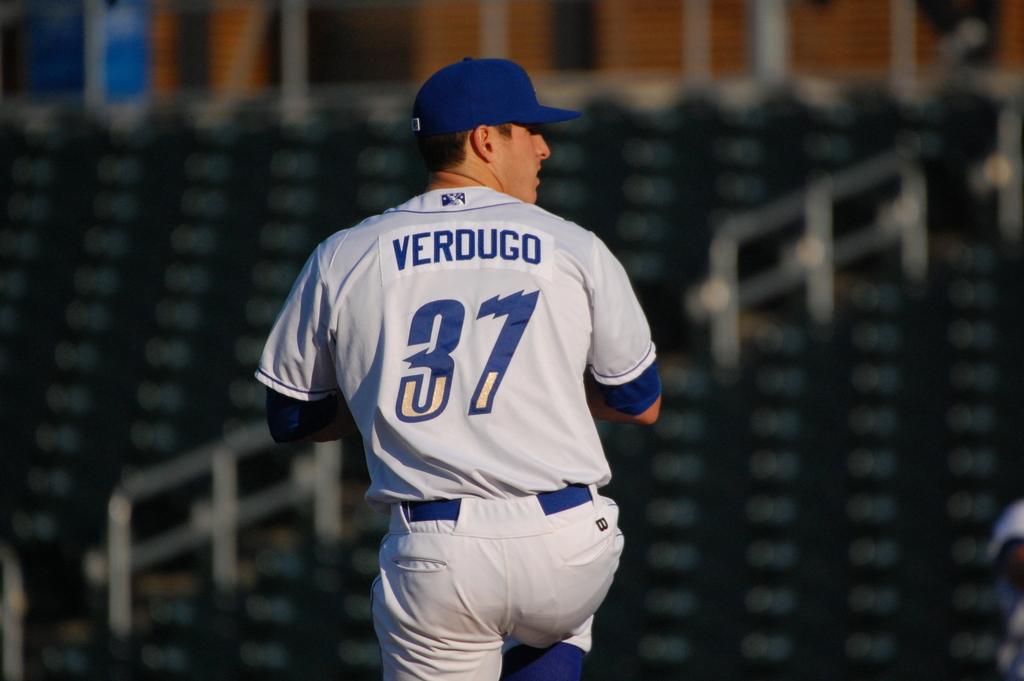What is this players name?
Make the answer very short. Verdugo. 